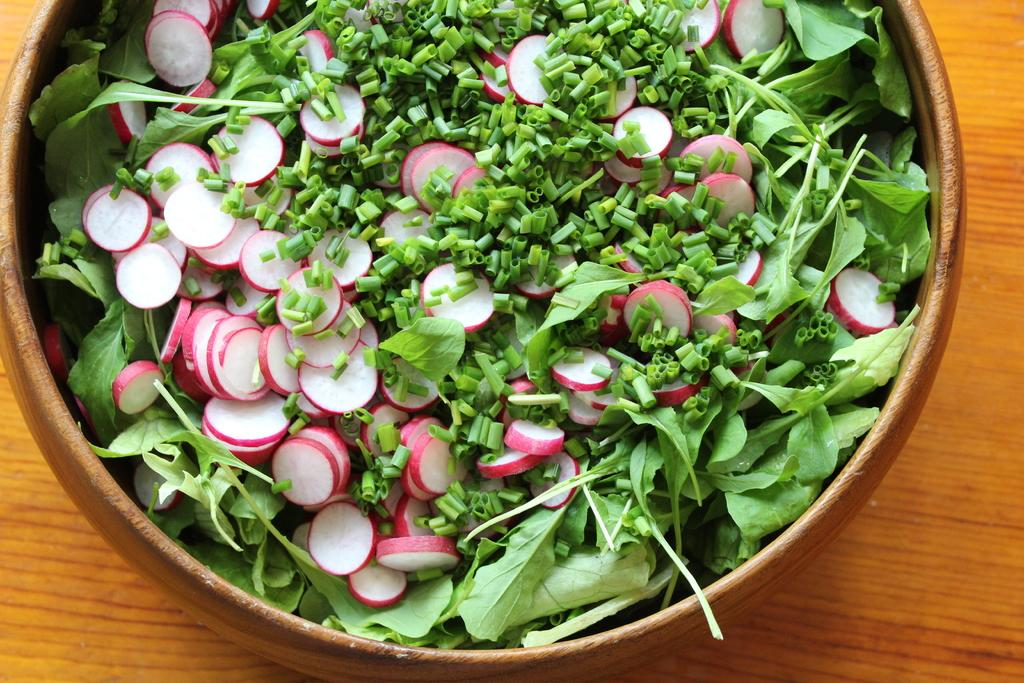What type of food is visible in the image? There are leafy vegetables and vegetable slices in the image. How are the vegetable slices arranged in the image? The vegetable slices are in a bowl. Where is the bowl with vegetable slices located? The bowl is placed on a table. Where is the playground located in the image? There is no playground present in the image. What type of jewelry is visible in the image? There is no jewelry, such as a locket, present in the image. 